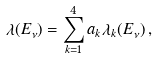<formula> <loc_0><loc_0><loc_500><loc_500>\lambda ( E _ { \nu } ) = \sum _ { k = 1 } ^ { 4 } a _ { k } \lambda _ { k } ( E _ { \nu } ) \, ,</formula> 